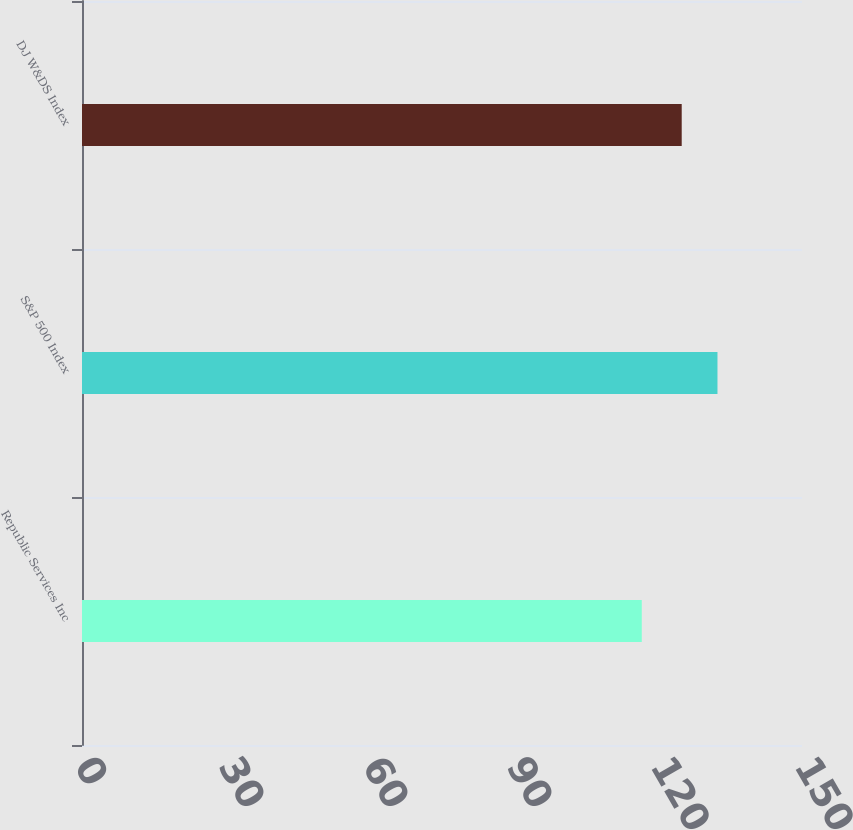<chart> <loc_0><loc_0><loc_500><loc_500><bar_chart><fcel>Republic Services Inc<fcel>S&P 500 Index<fcel>DJ W&DS Index<nl><fcel>116.62<fcel>132.39<fcel>124.94<nl></chart> 